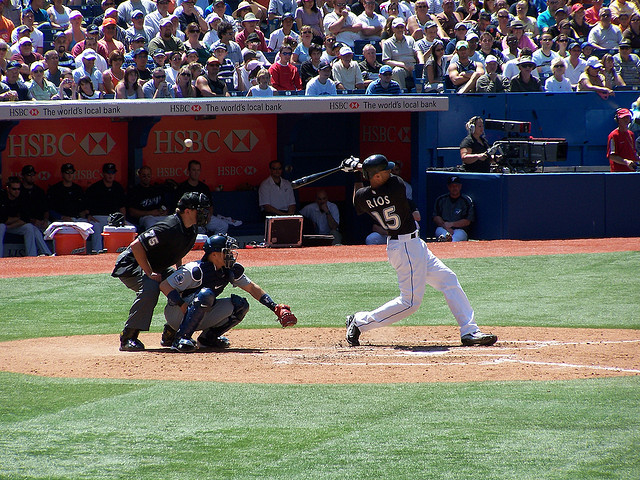Read and extract the text from this image. Rosi 15 HSBC HSBC bank world's The bank world's The HSBC local World's The HSBC HSBC 